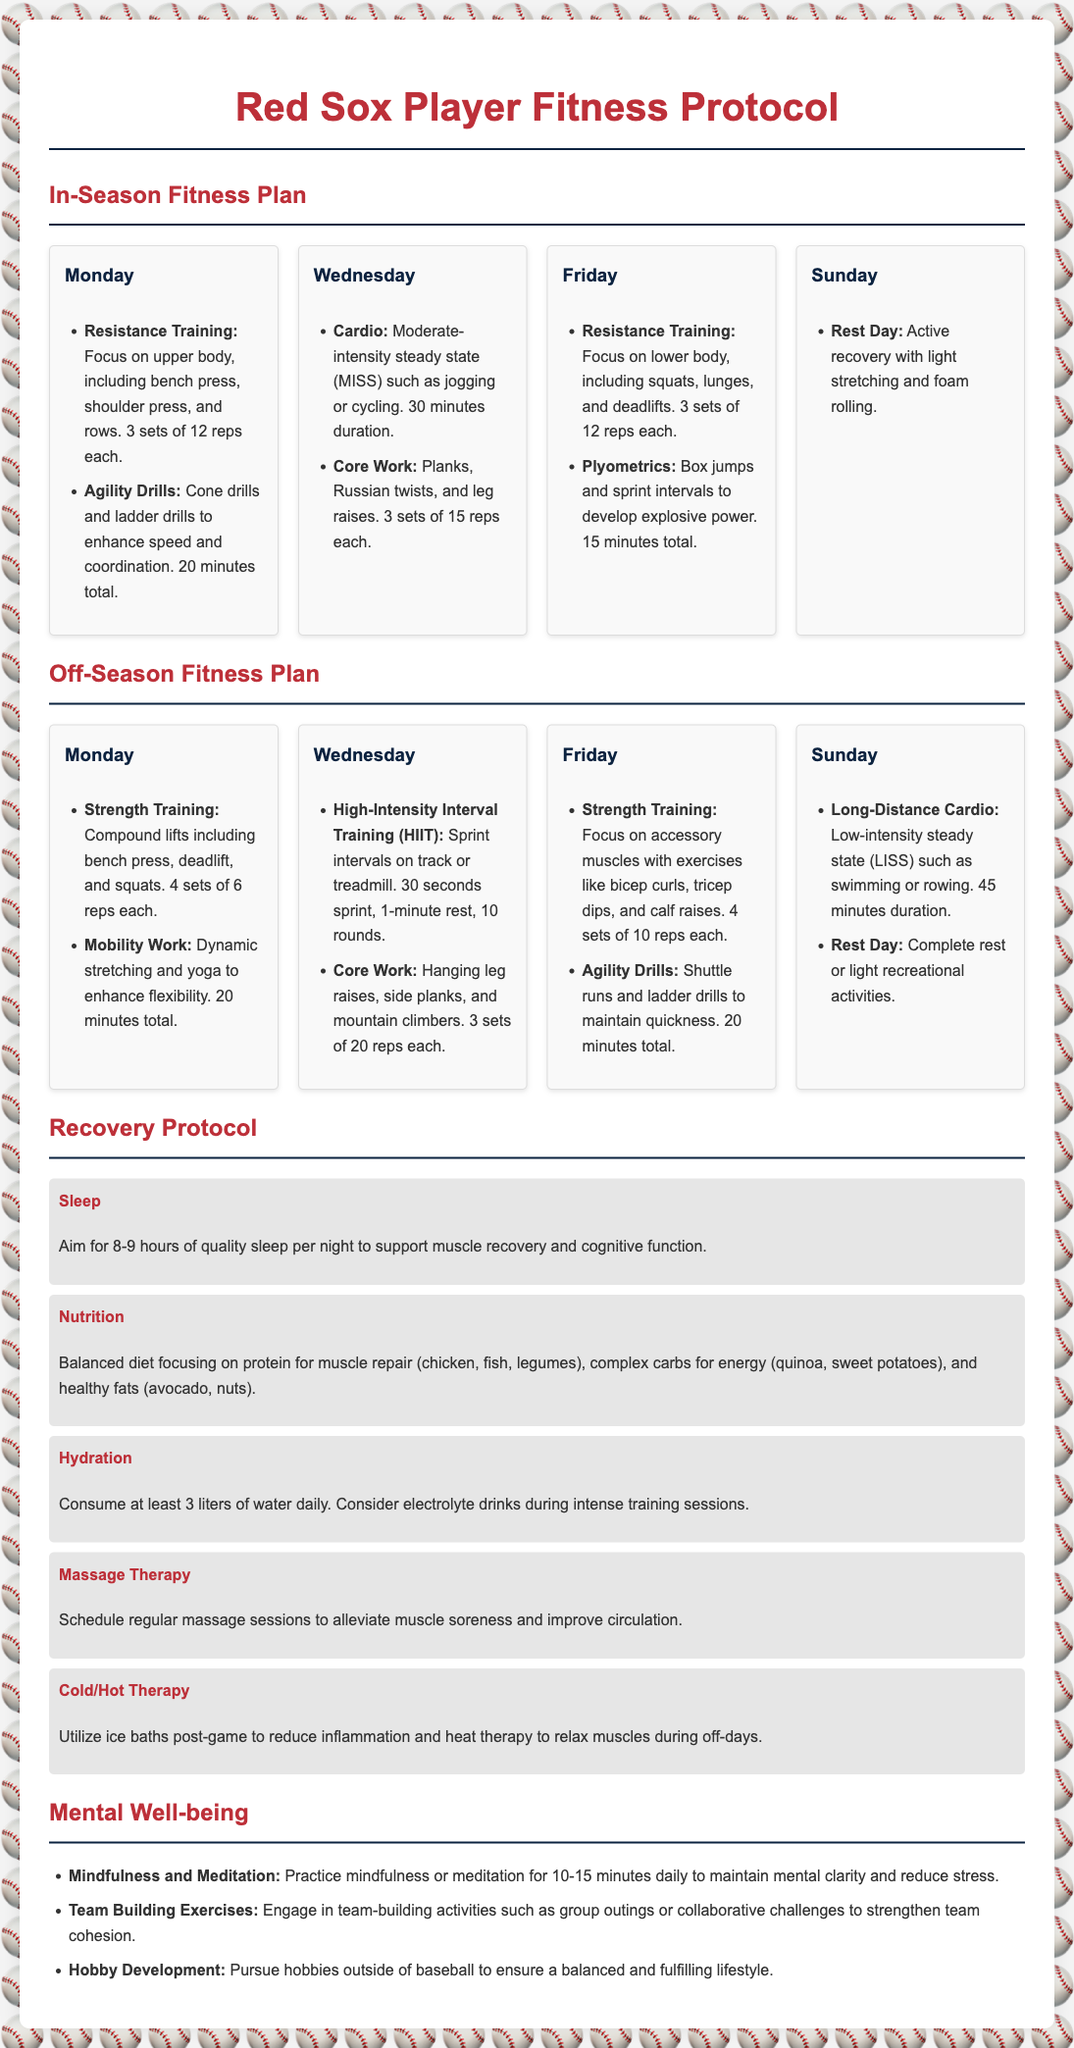What is the focus of Monday's in-season workout? The focus of Monday's in-season workout is on upper body resistance training and agility drills.
Answer: Upper body, agility drills How many sets and reps are prescribed for lower body resistance training on Fridays during the in-season? The document states that the lower body resistance training on Fridays consists of 3 sets of 12 reps each.
Answer: 3 sets of 12 reps What type of cardio is recommended for Wednesday's off-season workout? The recommended type of cardio for Wednesday's off-season workout is High-Intensity Interval Training (HIIT).
Answer: HIIT How long should the long-distance cardio session last on Sundays during the off-season? The long-distance cardio session on Sundays during the off-season should last for 45 minutes.
Answer: 45 minutes What is the recommended sleep duration for recovery? The recommended sleep duration for recovery is 8-9 hours.
Answer: 8-9 hours What is one of the key areas of focus in the recovery protocol? The recovery protocol emphasizes nutrition as a key area.
Answer: Nutrition How many cardio sessions are scheduled in the in-season plan? There are two cardio sessions scheduled, one on Wednesday and one on Friday.
Answer: Two sessions What type of therapy is suggested for muscle soreness relief? Massage therapy is suggested for alleviating muscle soreness.
Answer: Massage therapy 